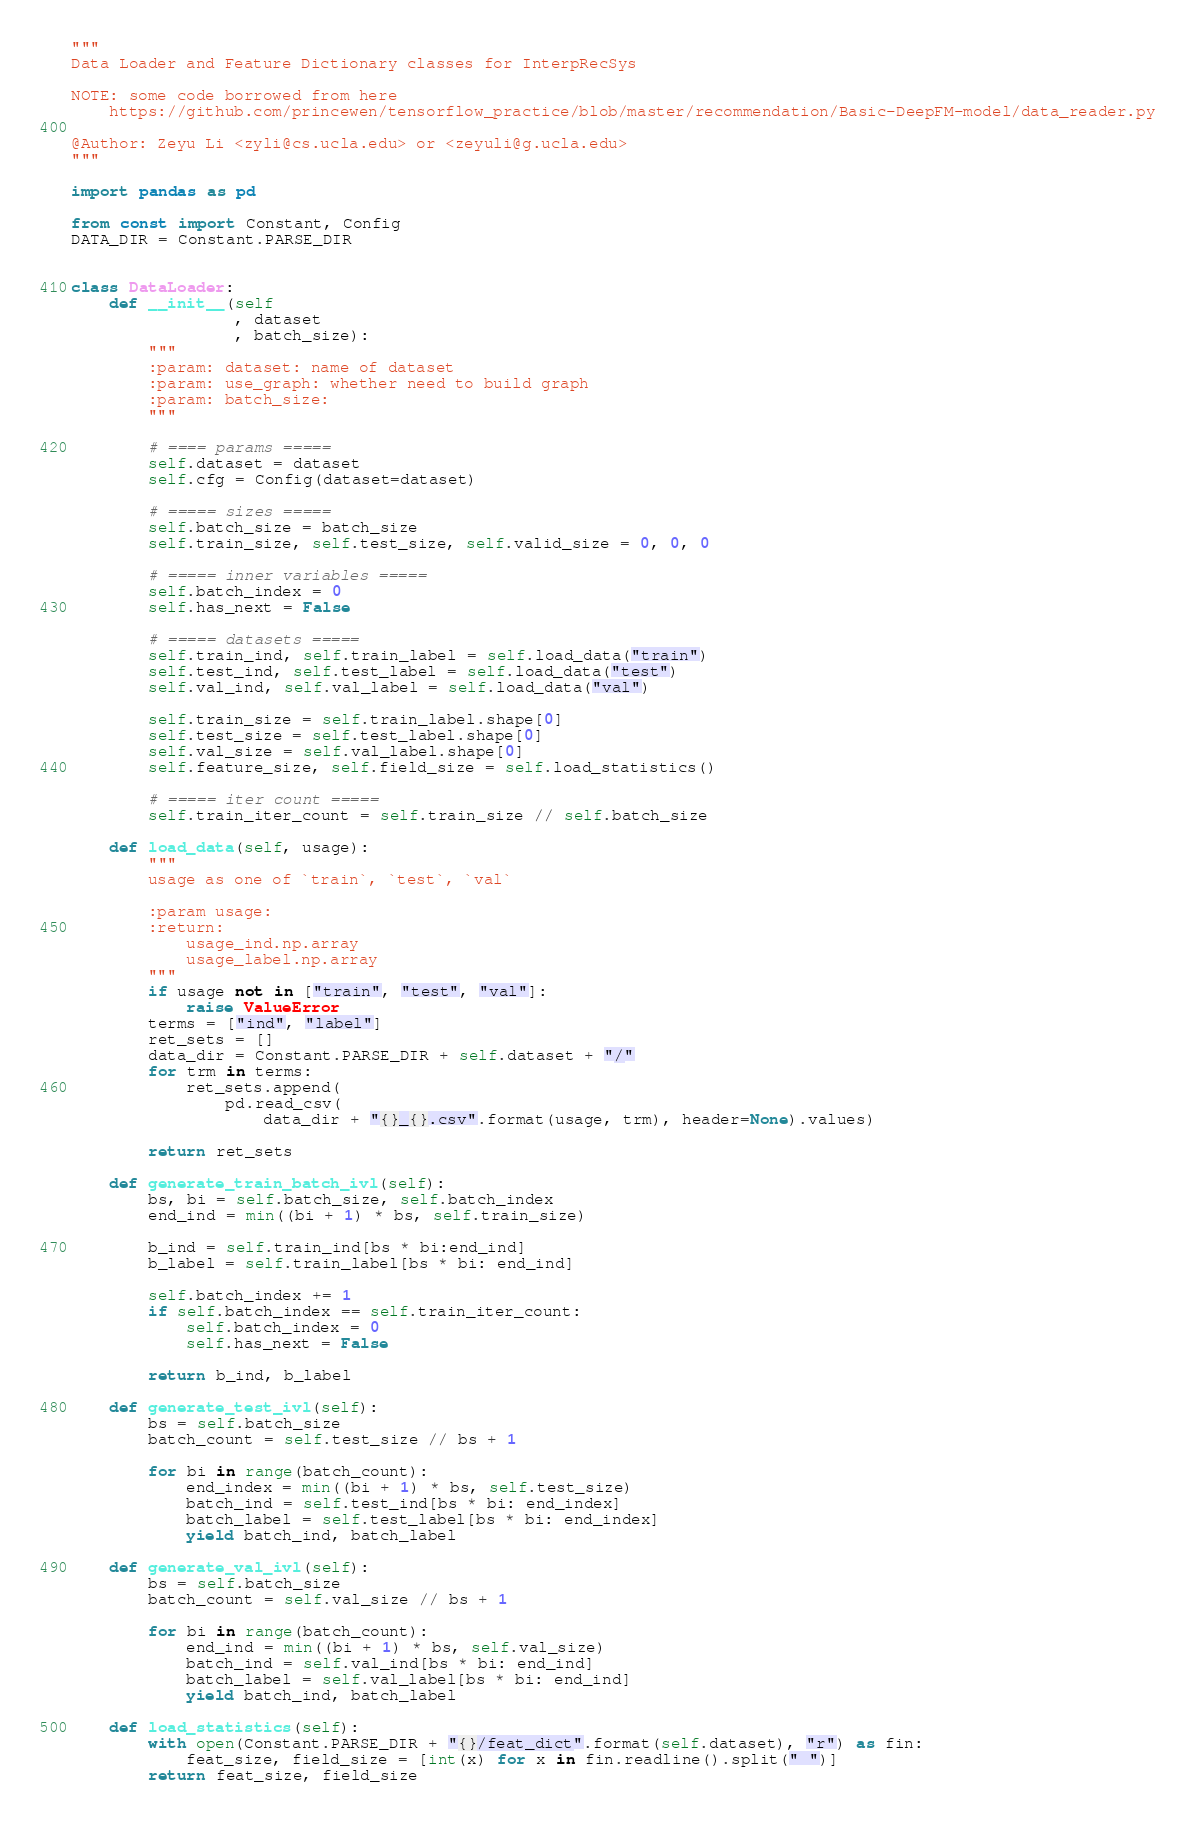<code> <loc_0><loc_0><loc_500><loc_500><_Python_>"""
Data Loader and Feature Dictionary classes for InterpRecSys

NOTE: some code borrowed from here
    https://github.com/princewen/tensorflow_practice/blob/master/recommendation/Basic-DeepFM-model/data_reader.py

@Author: Zeyu Li <zyli@cs.ucla.edu> or <zeyuli@g.ucla.edu>
"""

import pandas as pd

from const import Constant, Config
DATA_DIR = Constant.PARSE_DIR


class DataLoader:
    def __init__(self
                 , dataset
                 , batch_size):
        """
        :param: dataset: name of dataset
        :param: use_graph: whether need to build graph
        :param: batch_size:
        """

        # ==== params =====
        self.dataset = dataset
        self.cfg = Config(dataset=dataset)

        # ===== sizes =====
        self.batch_size = batch_size
        self.train_size, self.test_size, self.valid_size = 0, 0, 0

        # ===== inner variables =====
        self.batch_index = 0
        self.has_next = False

        # ===== datasets =====
        self.train_ind, self.train_label = self.load_data("train")
        self.test_ind, self.test_label = self.load_data("test")
        self.val_ind, self.val_label = self.load_data("val")

        self.train_size = self.train_label.shape[0]
        self.test_size = self.test_label.shape[0]
        self.val_size = self.val_label.shape[0]
        self.feature_size, self.field_size = self.load_statistics()

        # ===== iter count =====
        self.train_iter_count = self.train_size // self.batch_size

    def load_data(self, usage):
        """
        usage as one of `train`, `test`, `val`

        :param usage:
        :return:
            usage_ind.np.array
            usage_label.np.array
        """
        if usage not in ["train", "test", "val"]:
            raise ValueError
        terms = ["ind", "label"]
        ret_sets = []
        data_dir = Constant.PARSE_DIR + self.dataset + "/"
        for trm in terms:
            ret_sets.append(
                pd.read_csv(
                    data_dir + "{}_{}.csv".format(usage, trm), header=None).values)

        return ret_sets

    def generate_train_batch_ivl(self):
        bs, bi = self.batch_size, self.batch_index
        end_ind = min((bi + 1) * bs, self.train_size)

        b_ind = self.train_ind[bs * bi:end_ind]
        b_label = self.train_label[bs * bi: end_ind]

        self.batch_index += 1
        if self.batch_index == self.train_iter_count:
            self.batch_index = 0
            self.has_next = False

        return b_ind, b_label

    def generate_test_ivl(self):
        bs = self.batch_size
        batch_count = self.test_size // bs + 1

        for bi in range(batch_count):
            end_index = min((bi + 1) * bs, self.test_size)
            batch_ind = self.test_ind[bs * bi: end_index]
            batch_label = self.test_label[bs * bi: end_index]
            yield batch_ind, batch_label

    def generate_val_ivl(self):
        bs = self.batch_size
        batch_count = self.val_size // bs + 1

        for bi in range(batch_count):
            end_ind = min((bi + 1) * bs, self.val_size)
            batch_ind = self.val_ind[bs * bi: end_ind]
            batch_label = self.val_label[bs * bi: end_ind]
            yield batch_ind, batch_label

    def load_statistics(self):
        with open(Constant.PARSE_DIR + "{}/feat_dict".format(self.dataset), "r") as fin:
            feat_size, field_size = [int(x) for x in fin.readline().split(" ")]
        return feat_size, field_size



</code> 